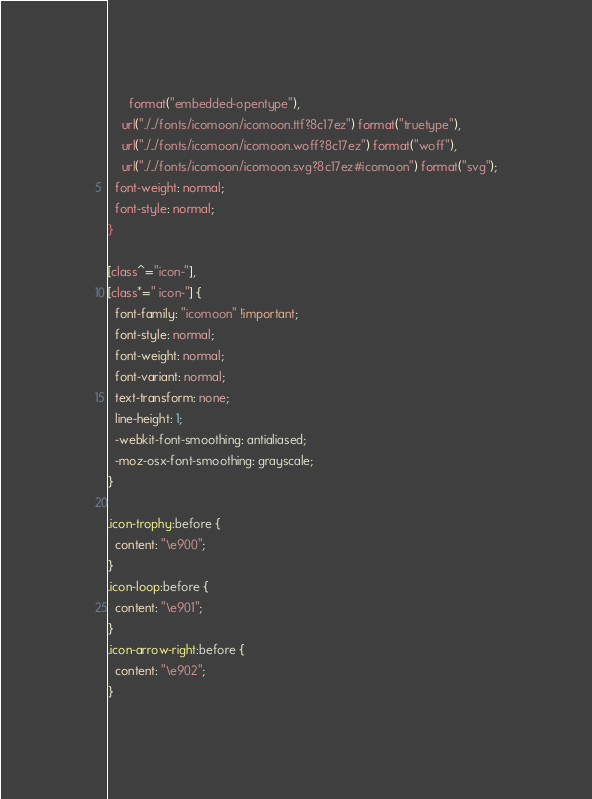<code> <loc_0><loc_0><loc_500><loc_500><_CSS_>      format("embedded-opentype"),
    url("./../fonts/icomoon/icomoon.ttf?8c17ez") format("truetype"),
    url("./../fonts/icomoon/icomoon.woff?8c17ez") format("woff"),
    url("./../fonts/icomoon/icomoon.svg?8c17ez#icomoon") format("svg");
  font-weight: normal;
  font-style: normal;
}

[class^="icon-"],
[class*=" icon-"] {
  font-family: "icomoon" !important;
  font-style: normal;
  font-weight: normal;
  font-variant: normal;
  text-transform: none;
  line-height: 1;
  -webkit-font-smoothing: antialiased;
  -moz-osx-font-smoothing: grayscale;
}

.icon-trophy:before {
  content: "\e900";
}
.icon-loop:before {
  content: "\e901";
}
.icon-arrow-right:before {
  content: "\e902";
}
</code> 